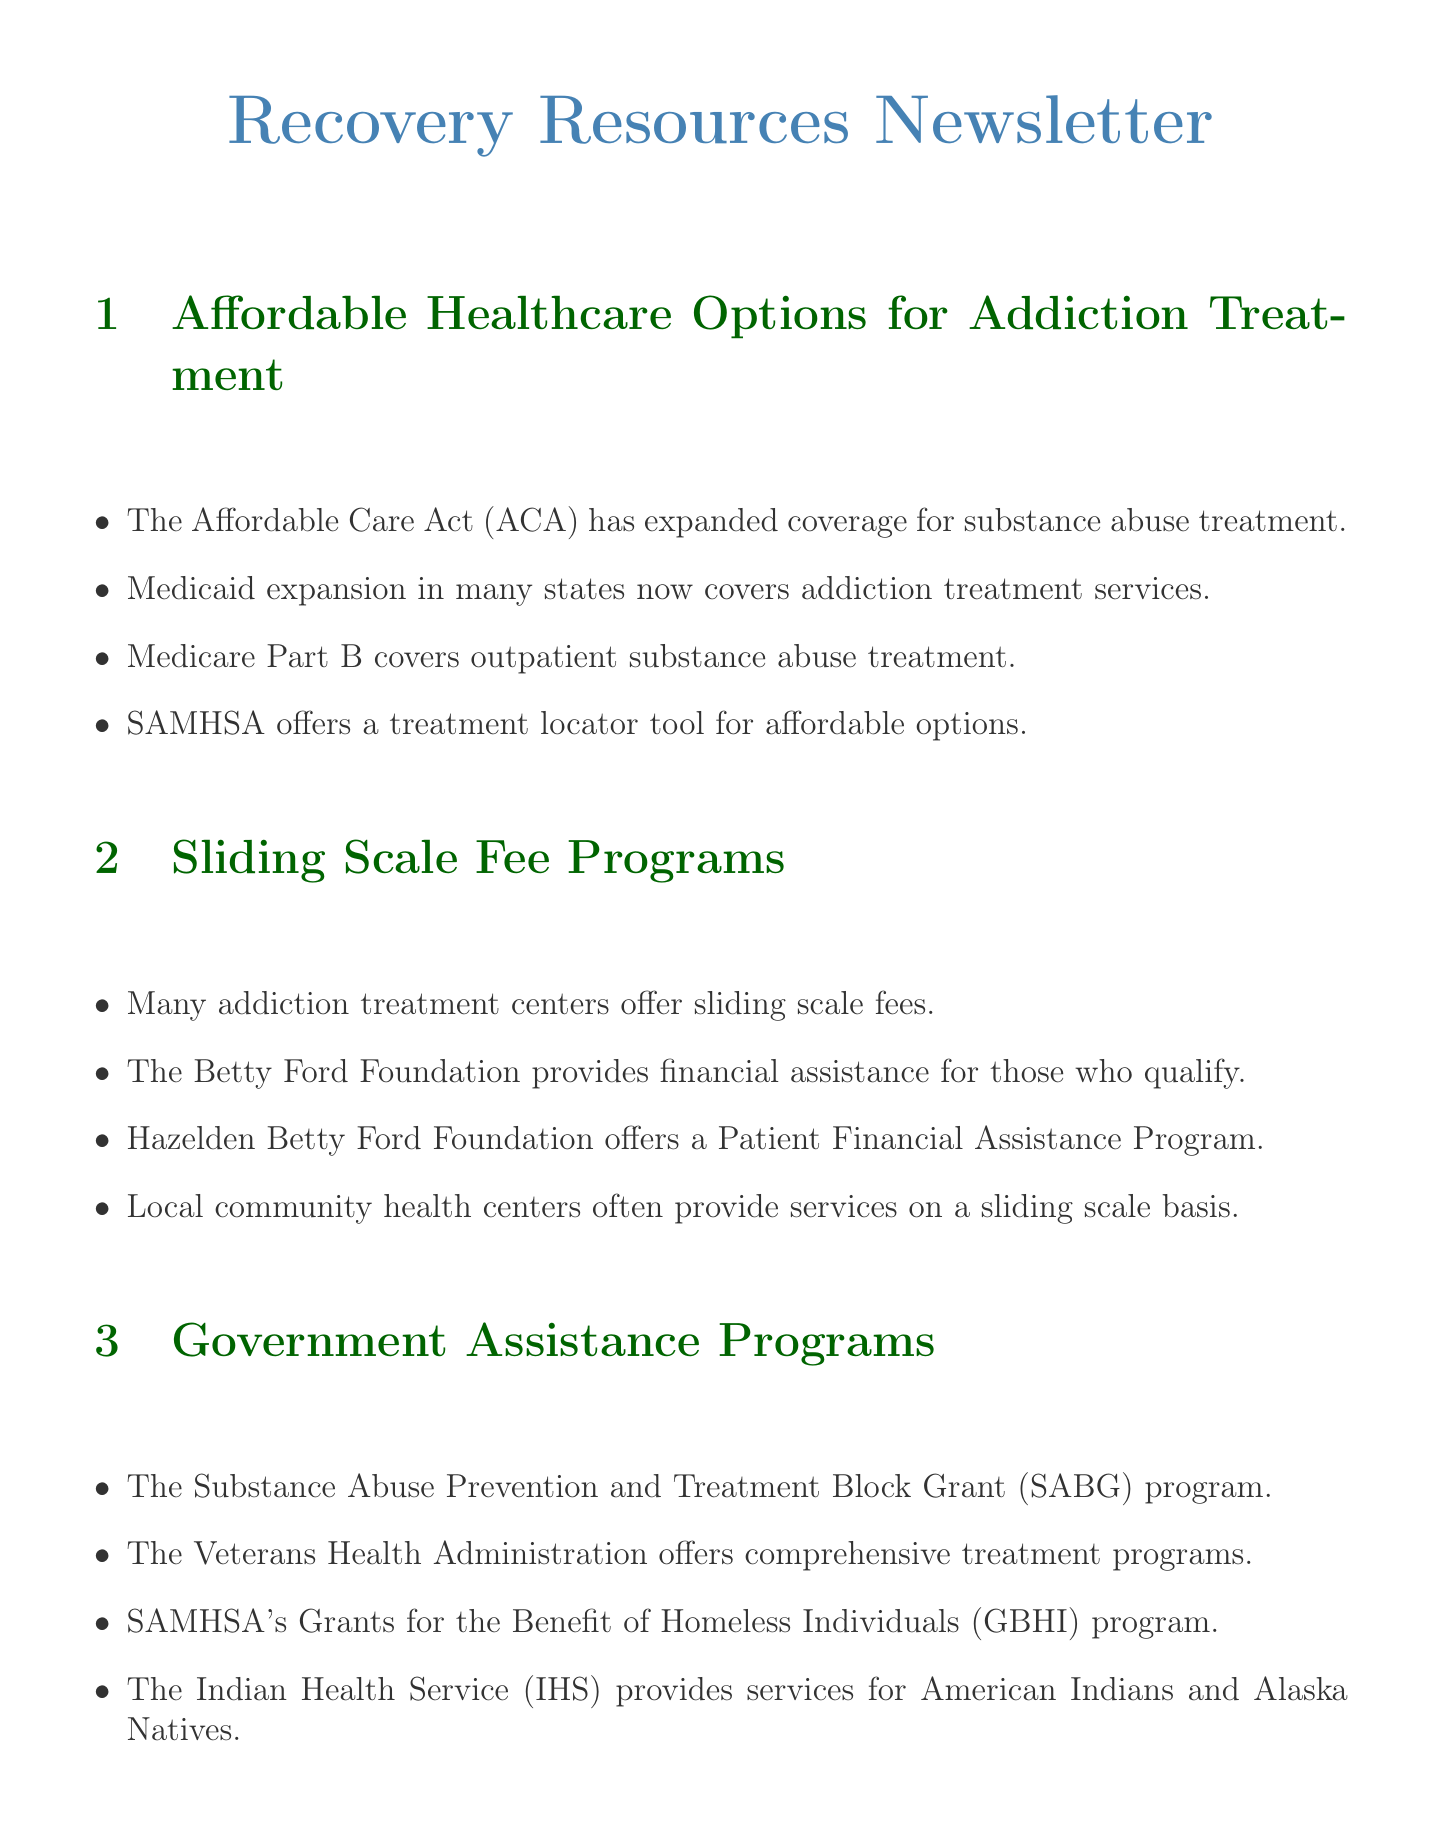What program has expanded coverage for substance abuse treatment? The document states that the Affordable Care Act (ACA) has expanded coverage for substance abuse treatment, making it more accessible for many Americans.
Answer: Affordable Care Act (ACA) Which organization offers a treatment locator tool? The document mentions that the Substance Abuse and Mental Health Services Administration (SAMHSA) offers a treatment locator tool to find affordable options near you.
Answer: SAMHSA What type of payment model do many addiction treatment centers use? The document indicates that many addiction treatment centers offer sliding scale fees based on income and ability to pay.
Answer: Sliding scale fees Which government program supports addiction treatment for homeless individuals? According to the document, SAMHSA's Grants for the Benefit of Homeless Individuals (GBHI) program supports substance abuse treatment for homeless individuals.
Answer: GBHI What is one resource where individuals can find free support groups? The document lists Alcoholics Anonymous (AA) and Narcotics Anonymous (NA) as free support group meetings available nationwide.
Answer: AA and NA How does the Veterans Health Administration assist eligible individuals? The document states that the Veterans Health Administration offers comprehensive substance use treatment programs for eligible veterans.
Answer: Substance use treatment programs What type of services does the Indian Health Service (IHS) provide? The document mentions that the Indian Health Service (IHS) provides addiction treatment services for American Indians and Alaska Natives.
Answer: Addiction treatment services Which organization provides financial assistance based on need? The document references the Betty Ford Foundation, which provides financial assistance for those who qualify, adjusting fees according to financial need.
Answer: Betty Ford Foundation Name a specific state-funded treatment option mentioned in the document. The document notes New York's Office of Addiction Services and Supports (OASAS) as a state-funded treatment option.
Answer: OASAS 